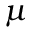Convert formula to latex. <formula><loc_0><loc_0><loc_500><loc_500>\mu</formula> 